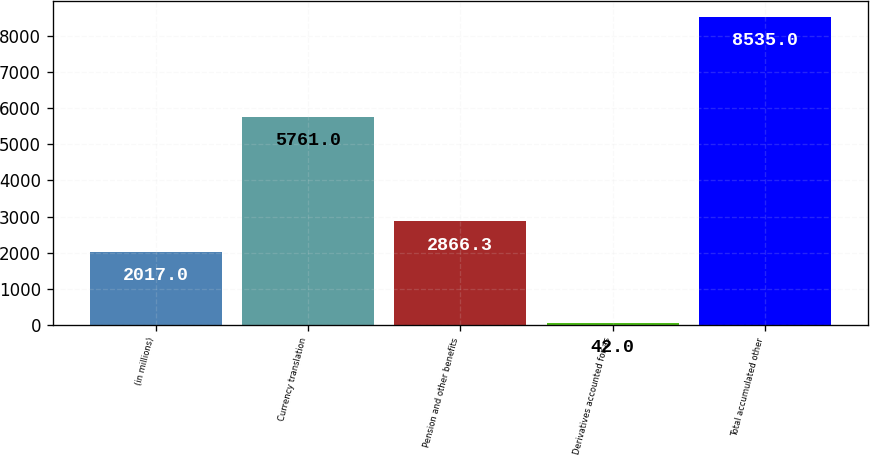Convert chart to OTSL. <chart><loc_0><loc_0><loc_500><loc_500><bar_chart><fcel>(in millions)<fcel>Currency translation<fcel>Pension and other benefits<fcel>Derivatives accounted for as<fcel>Total accumulated other<nl><fcel>2017<fcel>5761<fcel>2866.3<fcel>42<fcel>8535<nl></chart> 